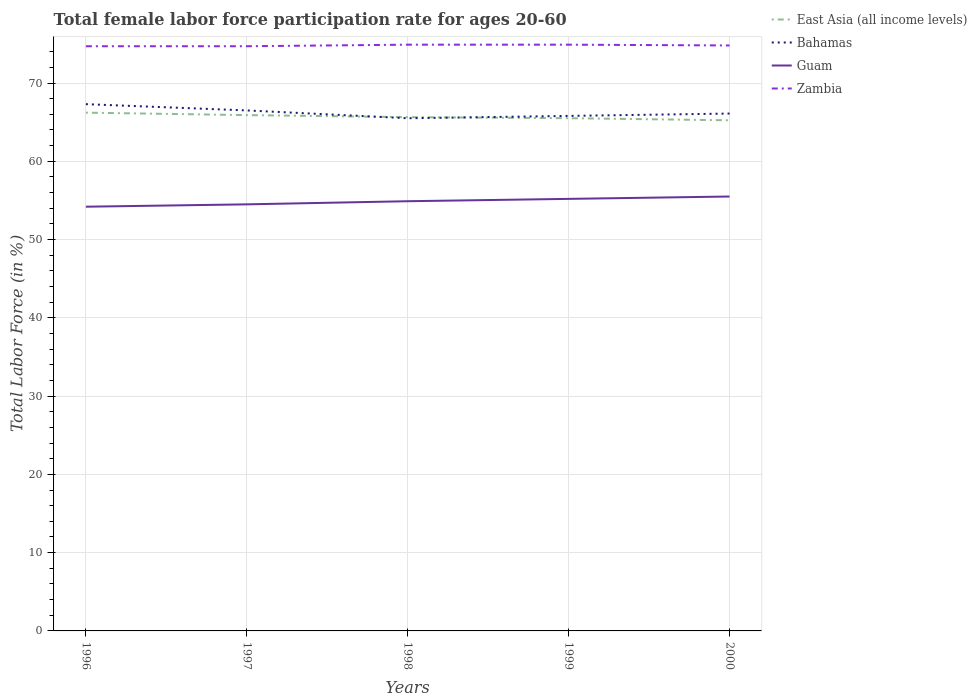Does the line corresponding to Zambia intersect with the line corresponding to Bahamas?
Provide a succinct answer. No. Across all years, what is the maximum female labor force participation rate in Zambia?
Provide a succinct answer. 74.7. In which year was the female labor force participation rate in East Asia (all income levels) maximum?
Ensure brevity in your answer.  2000. What is the total female labor force participation rate in Bahamas in the graph?
Offer a very short reply. 1.2. What is the difference between the highest and the second highest female labor force participation rate in Zambia?
Give a very brief answer. 0.2. What is the difference between the highest and the lowest female labor force participation rate in East Asia (all income levels)?
Your response must be concise. 2. Is the female labor force participation rate in Guam strictly greater than the female labor force participation rate in East Asia (all income levels) over the years?
Give a very brief answer. Yes. How many lines are there?
Offer a terse response. 4. How many years are there in the graph?
Make the answer very short. 5. Does the graph contain grids?
Your answer should be very brief. Yes. How many legend labels are there?
Keep it short and to the point. 4. How are the legend labels stacked?
Your response must be concise. Vertical. What is the title of the graph?
Your answer should be compact. Total female labor force participation rate for ages 20-60. What is the Total Labor Force (in %) in East Asia (all income levels) in 1996?
Ensure brevity in your answer.  66.22. What is the Total Labor Force (in %) in Bahamas in 1996?
Ensure brevity in your answer.  67.3. What is the Total Labor Force (in %) of Guam in 1996?
Provide a short and direct response. 54.2. What is the Total Labor Force (in %) of Zambia in 1996?
Your answer should be very brief. 74.7. What is the Total Labor Force (in %) in East Asia (all income levels) in 1997?
Ensure brevity in your answer.  65.9. What is the Total Labor Force (in %) of Bahamas in 1997?
Make the answer very short. 66.5. What is the Total Labor Force (in %) in Guam in 1997?
Ensure brevity in your answer.  54.5. What is the Total Labor Force (in %) in Zambia in 1997?
Your answer should be very brief. 74.7. What is the Total Labor Force (in %) of East Asia (all income levels) in 1998?
Give a very brief answer. 65.64. What is the Total Labor Force (in %) in Bahamas in 1998?
Ensure brevity in your answer.  65.5. What is the Total Labor Force (in %) in Guam in 1998?
Offer a very short reply. 54.9. What is the Total Labor Force (in %) in Zambia in 1998?
Offer a very short reply. 74.9. What is the Total Labor Force (in %) in East Asia (all income levels) in 1999?
Give a very brief answer. 65.51. What is the Total Labor Force (in %) of Bahamas in 1999?
Offer a very short reply. 65.8. What is the Total Labor Force (in %) in Guam in 1999?
Offer a terse response. 55.2. What is the Total Labor Force (in %) in Zambia in 1999?
Offer a very short reply. 74.9. What is the Total Labor Force (in %) of East Asia (all income levels) in 2000?
Your answer should be compact. 65.24. What is the Total Labor Force (in %) in Bahamas in 2000?
Make the answer very short. 66.1. What is the Total Labor Force (in %) in Guam in 2000?
Provide a short and direct response. 55.5. What is the Total Labor Force (in %) of Zambia in 2000?
Offer a very short reply. 74.8. Across all years, what is the maximum Total Labor Force (in %) of East Asia (all income levels)?
Provide a short and direct response. 66.22. Across all years, what is the maximum Total Labor Force (in %) of Bahamas?
Your response must be concise. 67.3. Across all years, what is the maximum Total Labor Force (in %) of Guam?
Ensure brevity in your answer.  55.5. Across all years, what is the maximum Total Labor Force (in %) of Zambia?
Offer a very short reply. 74.9. Across all years, what is the minimum Total Labor Force (in %) in East Asia (all income levels)?
Offer a terse response. 65.24. Across all years, what is the minimum Total Labor Force (in %) in Bahamas?
Provide a succinct answer. 65.5. Across all years, what is the minimum Total Labor Force (in %) of Guam?
Offer a very short reply. 54.2. Across all years, what is the minimum Total Labor Force (in %) of Zambia?
Your answer should be compact. 74.7. What is the total Total Labor Force (in %) in East Asia (all income levels) in the graph?
Give a very brief answer. 328.5. What is the total Total Labor Force (in %) in Bahamas in the graph?
Offer a very short reply. 331.2. What is the total Total Labor Force (in %) in Guam in the graph?
Provide a succinct answer. 274.3. What is the total Total Labor Force (in %) in Zambia in the graph?
Provide a succinct answer. 374. What is the difference between the Total Labor Force (in %) in East Asia (all income levels) in 1996 and that in 1997?
Ensure brevity in your answer.  0.31. What is the difference between the Total Labor Force (in %) of Bahamas in 1996 and that in 1997?
Give a very brief answer. 0.8. What is the difference between the Total Labor Force (in %) of Guam in 1996 and that in 1997?
Offer a terse response. -0.3. What is the difference between the Total Labor Force (in %) in Zambia in 1996 and that in 1997?
Ensure brevity in your answer.  0. What is the difference between the Total Labor Force (in %) of East Asia (all income levels) in 1996 and that in 1998?
Your answer should be compact. 0.58. What is the difference between the Total Labor Force (in %) in Bahamas in 1996 and that in 1998?
Your answer should be very brief. 1.8. What is the difference between the Total Labor Force (in %) of Guam in 1996 and that in 1998?
Your answer should be very brief. -0.7. What is the difference between the Total Labor Force (in %) in East Asia (all income levels) in 1996 and that in 1999?
Make the answer very short. 0.71. What is the difference between the Total Labor Force (in %) of East Asia (all income levels) in 1996 and that in 2000?
Your response must be concise. 0.98. What is the difference between the Total Labor Force (in %) in East Asia (all income levels) in 1997 and that in 1998?
Give a very brief answer. 0.26. What is the difference between the Total Labor Force (in %) of Bahamas in 1997 and that in 1998?
Offer a very short reply. 1. What is the difference between the Total Labor Force (in %) in Guam in 1997 and that in 1998?
Your response must be concise. -0.4. What is the difference between the Total Labor Force (in %) in East Asia (all income levels) in 1997 and that in 1999?
Ensure brevity in your answer.  0.39. What is the difference between the Total Labor Force (in %) of Bahamas in 1997 and that in 1999?
Your answer should be very brief. 0.7. What is the difference between the Total Labor Force (in %) in Guam in 1997 and that in 1999?
Offer a terse response. -0.7. What is the difference between the Total Labor Force (in %) in East Asia (all income levels) in 1997 and that in 2000?
Give a very brief answer. 0.66. What is the difference between the Total Labor Force (in %) in Bahamas in 1997 and that in 2000?
Provide a short and direct response. 0.4. What is the difference between the Total Labor Force (in %) in Zambia in 1997 and that in 2000?
Your answer should be compact. -0.1. What is the difference between the Total Labor Force (in %) in East Asia (all income levels) in 1998 and that in 1999?
Provide a succinct answer. 0.13. What is the difference between the Total Labor Force (in %) of Bahamas in 1998 and that in 1999?
Ensure brevity in your answer.  -0.3. What is the difference between the Total Labor Force (in %) of Guam in 1998 and that in 1999?
Provide a short and direct response. -0.3. What is the difference between the Total Labor Force (in %) in Zambia in 1998 and that in 1999?
Make the answer very short. 0. What is the difference between the Total Labor Force (in %) in East Asia (all income levels) in 1998 and that in 2000?
Your answer should be very brief. 0.4. What is the difference between the Total Labor Force (in %) of Bahamas in 1998 and that in 2000?
Make the answer very short. -0.6. What is the difference between the Total Labor Force (in %) of Guam in 1998 and that in 2000?
Your response must be concise. -0.6. What is the difference between the Total Labor Force (in %) of East Asia (all income levels) in 1999 and that in 2000?
Give a very brief answer. 0.27. What is the difference between the Total Labor Force (in %) in Bahamas in 1999 and that in 2000?
Give a very brief answer. -0.3. What is the difference between the Total Labor Force (in %) of East Asia (all income levels) in 1996 and the Total Labor Force (in %) of Bahamas in 1997?
Offer a very short reply. -0.28. What is the difference between the Total Labor Force (in %) in East Asia (all income levels) in 1996 and the Total Labor Force (in %) in Guam in 1997?
Provide a succinct answer. 11.72. What is the difference between the Total Labor Force (in %) of East Asia (all income levels) in 1996 and the Total Labor Force (in %) of Zambia in 1997?
Give a very brief answer. -8.48. What is the difference between the Total Labor Force (in %) of Bahamas in 1996 and the Total Labor Force (in %) of Guam in 1997?
Your answer should be compact. 12.8. What is the difference between the Total Labor Force (in %) in Bahamas in 1996 and the Total Labor Force (in %) in Zambia in 1997?
Ensure brevity in your answer.  -7.4. What is the difference between the Total Labor Force (in %) of Guam in 1996 and the Total Labor Force (in %) of Zambia in 1997?
Provide a succinct answer. -20.5. What is the difference between the Total Labor Force (in %) of East Asia (all income levels) in 1996 and the Total Labor Force (in %) of Bahamas in 1998?
Provide a short and direct response. 0.72. What is the difference between the Total Labor Force (in %) in East Asia (all income levels) in 1996 and the Total Labor Force (in %) in Guam in 1998?
Make the answer very short. 11.32. What is the difference between the Total Labor Force (in %) of East Asia (all income levels) in 1996 and the Total Labor Force (in %) of Zambia in 1998?
Your answer should be compact. -8.68. What is the difference between the Total Labor Force (in %) in Bahamas in 1996 and the Total Labor Force (in %) in Guam in 1998?
Your answer should be compact. 12.4. What is the difference between the Total Labor Force (in %) in Bahamas in 1996 and the Total Labor Force (in %) in Zambia in 1998?
Provide a short and direct response. -7.6. What is the difference between the Total Labor Force (in %) in Guam in 1996 and the Total Labor Force (in %) in Zambia in 1998?
Offer a very short reply. -20.7. What is the difference between the Total Labor Force (in %) in East Asia (all income levels) in 1996 and the Total Labor Force (in %) in Bahamas in 1999?
Provide a short and direct response. 0.42. What is the difference between the Total Labor Force (in %) of East Asia (all income levels) in 1996 and the Total Labor Force (in %) of Guam in 1999?
Your answer should be compact. 11.02. What is the difference between the Total Labor Force (in %) in East Asia (all income levels) in 1996 and the Total Labor Force (in %) in Zambia in 1999?
Make the answer very short. -8.68. What is the difference between the Total Labor Force (in %) in Guam in 1996 and the Total Labor Force (in %) in Zambia in 1999?
Offer a terse response. -20.7. What is the difference between the Total Labor Force (in %) of East Asia (all income levels) in 1996 and the Total Labor Force (in %) of Bahamas in 2000?
Offer a very short reply. 0.12. What is the difference between the Total Labor Force (in %) in East Asia (all income levels) in 1996 and the Total Labor Force (in %) in Guam in 2000?
Offer a terse response. 10.72. What is the difference between the Total Labor Force (in %) in East Asia (all income levels) in 1996 and the Total Labor Force (in %) in Zambia in 2000?
Your answer should be very brief. -8.58. What is the difference between the Total Labor Force (in %) in Bahamas in 1996 and the Total Labor Force (in %) in Zambia in 2000?
Your answer should be very brief. -7.5. What is the difference between the Total Labor Force (in %) of Guam in 1996 and the Total Labor Force (in %) of Zambia in 2000?
Your response must be concise. -20.6. What is the difference between the Total Labor Force (in %) in East Asia (all income levels) in 1997 and the Total Labor Force (in %) in Bahamas in 1998?
Offer a terse response. 0.4. What is the difference between the Total Labor Force (in %) in East Asia (all income levels) in 1997 and the Total Labor Force (in %) in Guam in 1998?
Make the answer very short. 11. What is the difference between the Total Labor Force (in %) in East Asia (all income levels) in 1997 and the Total Labor Force (in %) in Zambia in 1998?
Provide a succinct answer. -9. What is the difference between the Total Labor Force (in %) of Guam in 1997 and the Total Labor Force (in %) of Zambia in 1998?
Provide a short and direct response. -20.4. What is the difference between the Total Labor Force (in %) of East Asia (all income levels) in 1997 and the Total Labor Force (in %) of Bahamas in 1999?
Your answer should be compact. 0.1. What is the difference between the Total Labor Force (in %) in East Asia (all income levels) in 1997 and the Total Labor Force (in %) in Guam in 1999?
Your answer should be compact. 10.7. What is the difference between the Total Labor Force (in %) of East Asia (all income levels) in 1997 and the Total Labor Force (in %) of Zambia in 1999?
Your response must be concise. -9. What is the difference between the Total Labor Force (in %) of Bahamas in 1997 and the Total Labor Force (in %) of Guam in 1999?
Provide a short and direct response. 11.3. What is the difference between the Total Labor Force (in %) in Bahamas in 1997 and the Total Labor Force (in %) in Zambia in 1999?
Offer a terse response. -8.4. What is the difference between the Total Labor Force (in %) in Guam in 1997 and the Total Labor Force (in %) in Zambia in 1999?
Offer a very short reply. -20.4. What is the difference between the Total Labor Force (in %) in East Asia (all income levels) in 1997 and the Total Labor Force (in %) in Bahamas in 2000?
Your answer should be compact. -0.2. What is the difference between the Total Labor Force (in %) of East Asia (all income levels) in 1997 and the Total Labor Force (in %) of Guam in 2000?
Offer a very short reply. 10.4. What is the difference between the Total Labor Force (in %) in East Asia (all income levels) in 1997 and the Total Labor Force (in %) in Zambia in 2000?
Ensure brevity in your answer.  -8.9. What is the difference between the Total Labor Force (in %) in Bahamas in 1997 and the Total Labor Force (in %) in Guam in 2000?
Offer a terse response. 11. What is the difference between the Total Labor Force (in %) of Bahamas in 1997 and the Total Labor Force (in %) of Zambia in 2000?
Provide a short and direct response. -8.3. What is the difference between the Total Labor Force (in %) in Guam in 1997 and the Total Labor Force (in %) in Zambia in 2000?
Keep it short and to the point. -20.3. What is the difference between the Total Labor Force (in %) of East Asia (all income levels) in 1998 and the Total Labor Force (in %) of Bahamas in 1999?
Make the answer very short. -0.16. What is the difference between the Total Labor Force (in %) of East Asia (all income levels) in 1998 and the Total Labor Force (in %) of Guam in 1999?
Offer a very short reply. 10.44. What is the difference between the Total Labor Force (in %) in East Asia (all income levels) in 1998 and the Total Labor Force (in %) in Zambia in 1999?
Give a very brief answer. -9.26. What is the difference between the Total Labor Force (in %) in Bahamas in 1998 and the Total Labor Force (in %) in Guam in 1999?
Your response must be concise. 10.3. What is the difference between the Total Labor Force (in %) of Bahamas in 1998 and the Total Labor Force (in %) of Zambia in 1999?
Your answer should be compact. -9.4. What is the difference between the Total Labor Force (in %) of Guam in 1998 and the Total Labor Force (in %) of Zambia in 1999?
Provide a short and direct response. -20. What is the difference between the Total Labor Force (in %) in East Asia (all income levels) in 1998 and the Total Labor Force (in %) in Bahamas in 2000?
Your answer should be compact. -0.46. What is the difference between the Total Labor Force (in %) of East Asia (all income levels) in 1998 and the Total Labor Force (in %) of Guam in 2000?
Your answer should be compact. 10.14. What is the difference between the Total Labor Force (in %) of East Asia (all income levels) in 1998 and the Total Labor Force (in %) of Zambia in 2000?
Provide a short and direct response. -9.16. What is the difference between the Total Labor Force (in %) in Guam in 1998 and the Total Labor Force (in %) in Zambia in 2000?
Keep it short and to the point. -19.9. What is the difference between the Total Labor Force (in %) in East Asia (all income levels) in 1999 and the Total Labor Force (in %) in Bahamas in 2000?
Ensure brevity in your answer.  -0.59. What is the difference between the Total Labor Force (in %) in East Asia (all income levels) in 1999 and the Total Labor Force (in %) in Guam in 2000?
Give a very brief answer. 10.01. What is the difference between the Total Labor Force (in %) of East Asia (all income levels) in 1999 and the Total Labor Force (in %) of Zambia in 2000?
Your answer should be very brief. -9.29. What is the difference between the Total Labor Force (in %) in Bahamas in 1999 and the Total Labor Force (in %) in Zambia in 2000?
Offer a terse response. -9. What is the difference between the Total Labor Force (in %) of Guam in 1999 and the Total Labor Force (in %) of Zambia in 2000?
Offer a terse response. -19.6. What is the average Total Labor Force (in %) of East Asia (all income levels) per year?
Your response must be concise. 65.7. What is the average Total Labor Force (in %) of Bahamas per year?
Make the answer very short. 66.24. What is the average Total Labor Force (in %) in Guam per year?
Provide a succinct answer. 54.86. What is the average Total Labor Force (in %) of Zambia per year?
Provide a succinct answer. 74.8. In the year 1996, what is the difference between the Total Labor Force (in %) in East Asia (all income levels) and Total Labor Force (in %) in Bahamas?
Provide a short and direct response. -1.08. In the year 1996, what is the difference between the Total Labor Force (in %) of East Asia (all income levels) and Total Labor Force (in %) of Guam?
Provide a succinct answer. 12.02. In the year 1996, what is the difference between the Total Labor Force (in %) of East Asia (all income levels) and Total Labor Force (in %) of Zambia?
Your response must be concise. -8.48. In the year 1996, what is the difference between the Total Labor Force (in %) of Bahamas and Total Labor Force (in %) of Guam?
Your answer should be compact. 13.1. In the year 1996, what is the difference between the Total Labor Force (in %) in Guam and Total Labor Force (in %) in Zambia?
Offer a terse response. -20.5. In the year 1997, what is the difference between the Total Labor Force (in %) of East Asia (all income levels) and Total Labor Force (in %) of Bahamas?
Ensure brevity in your answer.  -0.6. In the year 1997, what is the difference between the Total Labor Force (in %) of East Asia (all income levels) and Total Labor Force (in %) of Guam?
Your answer should be compact. 11.4. In the year 1997, what is the difference between the Total Labor Force (in %) of East Asia (all income levels) and Total Labor Force (in %) of Zambia?
Offer a terse response. -8.8. In the year 1997, what is the difference between the Total Labor Force (in %) in Bahamas and Total Labor Force (in %) in Zambia?
Give a very brief answer. -8.2. In the year 1997, what is the difference between the Total Labor Force (in %) of Guam and Total Labor Force (in %) of Zambia?
Offer a terse response. -20.2. In the year 1998, what is the difference between the Total Labor Force (in %) of East Asia (all income levels) and Total Labor Force (in %) of Bahamas?
Your response must be concise. 0.14. In the year 1998, what is the difference between the Total Labor Force (in %) of East Asia (all income levels) and Total Labor Force (in %) of Guam?
Offer a terse response. 10.74. In the year 1998, what is the difference between the Total Labor Force (in %) in East Asia (all income levels) and Total Labor Force (in %) in Zambia?
Your answer should be very brief. -9.26. In the year 1999, what is the difference between the Total Labor Force (in %) in East Asia (all income levels) and Total Labor Force (in %) in Bahamas?
Your answer should be compact. -0.29. In the year 1999, what is the difference between the Total Labor Force (in %) in East Asia (all income levels) and Total Labor Force (in %) in Guam?
Your response must be concise. 10.31. In the year 1999, what is the difference between the Total Labor Force (in %) in East Asia (all income levels) and Total Labor Force (in %) in Zambia?
Your response must be concise. -9.39. In the year 1999, what is the difference between the Total Labor Force (in %) in Bahamas and Total Labor Force (in %) in Guam?
Your answer should be very brief. 10.6. In the year 1999, what is the difference between the Total Labor Force (in %) in Guam and Total Labor Force (in %) in Zambia?
Offer a terse response. -19.7. In the year 2000, what is the difference between the Total Labor Force (in %) of East Asia (all income levels) and Total Labor Force (in %) of Bahamas?
Offer a terse response. -0.86. In the year 2000, what is the difference between the Total Labor Force (in %) of East Asia (all income levels) and Total Labor Force (in %) of Guam?
Your answer should be very brief. 9.74. In the year 2000, what is the difference between the Total Labor Force (in %) in East Asia (all income levels) and Total Labor Force (in %) in Zambia?
Provide a succinct answer. -9.56. In the year 2000, what is the difference between the Total Labor Force (in %) of Bahamas and Total Labor Force (in %) of Guam?
Your answer should be very brief. 10.6. In the year 2000, what is the difference between the Total Labor Force (in %) in Bahamas and Total Labor Force (in %) in Zambia?
Your answer should be compact. -8.7. In the year 2000, what is the difference between the Total Labor Force (in %) in Guam and Total Labor Force (in %) in Zambia?
Give a very brief answer. -19.3. What is the ratio of the Total Labor Force (in %) of Zambia in 1996 to that in 1997?
Your response must be concise. 1. What is the ratio of the Total Labor Force (in %) of East Asia (all income levels) in 1996 to that in 1998?
Provide a short and direct response. 1.01. What is the ratio of the Total Labor Force (in %) of Bahamas in 1996 to that in 1998?
Give a very brief answer. 1.03. What is the ratio of the Total Labor Force (in %) in Guam in 1996 to that in 1998?
Your answer should be very brief. 0.99. What is the ratio of the Total Labor Force (in %) of East Asia (all income levels) in 1996 to that in 1999?
Offer a terse response. 1.01. What is the ratio of the Total Labor Force (in %) in Bahamas in 1996 to that in 1999?
Provide a short and direct response. 1.02. What is the ratio of the Total Labor Force (in %) of Guam in 1996 to that in 1999?
Give a very brief answer. 0.98. What is the ratio of the Total Labor Force (in %) of Zambia in 1996 to that in 1999?
Ensure brevity in your answer.  1. What is the ratio of the Total Labor Force (in %) of East Asia (all income levels) in 1996 to that in 2000?
Your answer should be very brief. 1.01. What is the ratio of the Total Labor Force (in %) of Bahamas in 1996 to that in 2000?
Offer a terse response. 1.02. What is the ratio of the Total Labor Force (in %) in Guam in 1996 to that in 2000?
Offer a terse response. 0.98. What is the ratio of the Total Labor Force (in %) of Zambia in 1996 to that in 2000?
Your response must be concise. 1. What is the ratio of the Total Labor Force (in %) in Bahamas in 1997 to that in 1998?
Your answer should be very brief. 1.02. What is the ratio of the Total Labor Force (in %) in East Asia (all income levels) in 1997 to that in 1999?
Your response must be concise. 1.01. What is the ratio of the Total Labor Force (in %) of Bahamas in 1997 to that in 1999?
Ensure brevity in your answer.  1.01. What is the ratio of the Total Labor Force (in %) in Guam in 1997 to that in 1999?
Provide a succinct answer. 0.99. What is the ratio of the Total Labor Force (in %) of Guam in 1997 to that in 2000?
Provide a succinct answer. 0.98. What is the ratio of the Total Labor Force (in %) in Zambia in 1998 to that in 1999?
Ensure brevity in your answer.  1. What is the ratio of the Total Labor Force (in %) of Bahamas in 1998 to that in 2000?
Give a very brief answer. 0.99. What is the ratio of the Total Labor Force (in %) of Zambia in 1998 to that in 2000?
Offer a terse response. 1. What is the ratio of the Total Labor Force (in %) in Bahamas in 1999 to that in 2000?
Provide a short and direct response. 1. What is the ratio of the Total Labor Force (in %) of Guam in 1999 to that in 2000?
Offer a very short reply. 0.99. What is the ratio of the Total Labor Force (in %) of Zambia in 1999 to that in 2000?
Keep it short and to the point. 1. What is the difference between the highest and the second highest Total Labor Force (in %) in East Asia (all income levels)?
Provide a short and direct response. 0.31. What is the difference between the highest and the second highest Total Labor Force (in %) in Guam?
Give a very brief answer. 0.3. What is the difference between the highest and the lowest Total Labor Force (in %) of East Asia (all income levels)?
Provide a succinct answer. 0.98. What is the difference between the highest and the lowest Total Labor Force (in %) in Bahamas?
Your response must be concise. 1.8. What is the difference between the highest and the lowest Total Labor Force (in %) in Guam?
Your response must be concise. 1.3. What is the difference between the highest and the lowest Total Labor Force (in %) in Zambia?
Offer a very short reply. 0.2. 